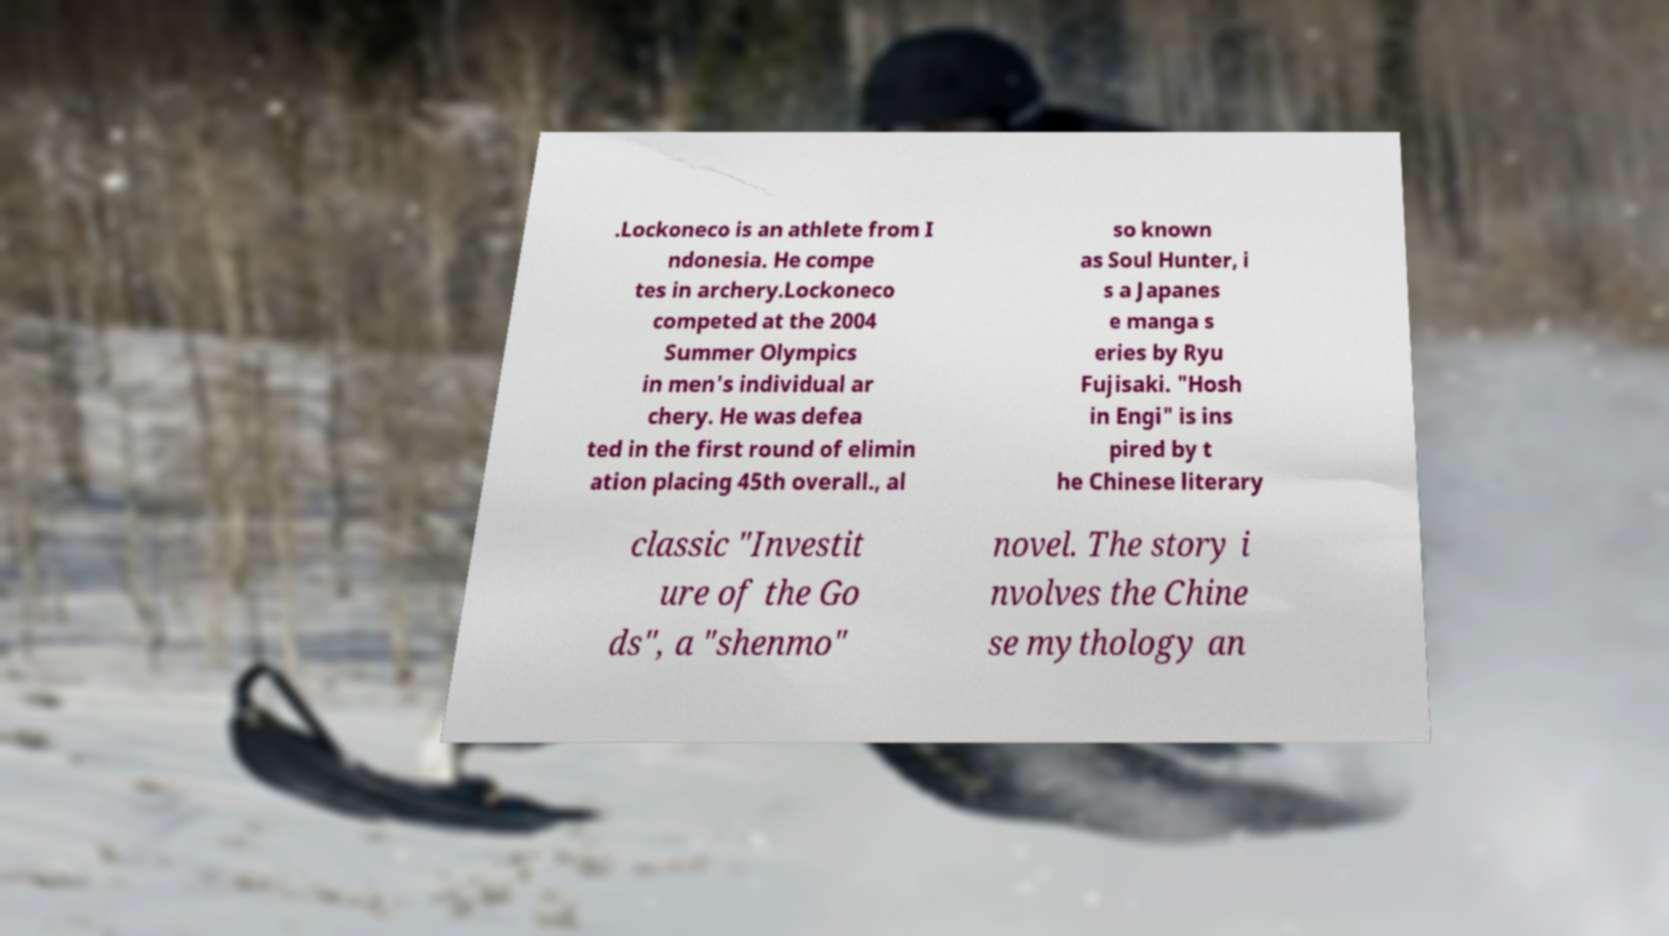Can you read and provide the text displayed in the image?This photo seems to have some interesting text. Can you extract and type it out for me? .Lockoneco is an athlete from I ndonesia. He compe tes in archery.Lockoneco competed at the 2004 Summer Olympics in men's individual ar chery. He was defea ted in the first round of elimin ation placing 45th overall., al so known as Soul Hunter, i s a Japanes e manga s eries by Ryu Fujisaki. "Hosh in Engi" is ins pired by t he Chinese literary classic "Investit ure of the Go ds", a "shenmo" novel. The story i nvolves the Chine se mythology an 